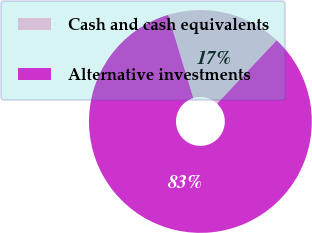Convert chart. <chart><loc_0><loc_0><loc_500><loc_500><pie_chart><fcel>Cash and cash equivalents<fcel>Alternative investments<nl><fcel>16.67%<fcel>83.33%<nl></chart> 